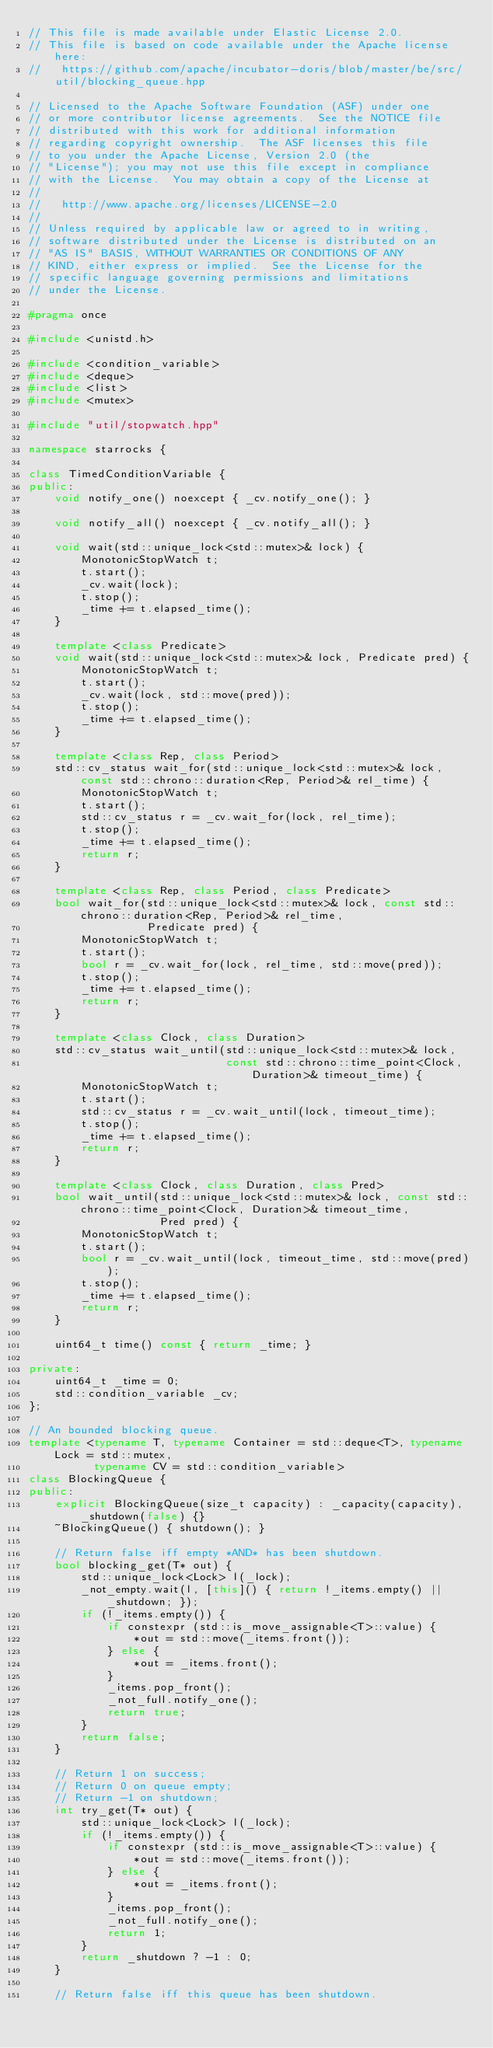Convert code to text. <code><loc_0><loc_0><loc_500><loc_500><_C++_>// This file is made available under Elastic License 2.0.
// This file is based on code available under the Apache license here:
//   https://github.com/apache/incubator-doris/blob/master/be/src/util/blocking_queue.hpp

// Licensed to the Apache Software Foundation (ASF) under one
// or more contributor license agreements.  See the NOTICE file
// distributed with this work for additional information
// regarding copyright ownership.  The ASF licenses this file
// to you under the Apache License, Version 2.0 (the
// "License"); you may not use this file except in compliance
// with the License.  You may obtain a copy of the License at
//
//   http://www.apache.org/licenses/LICENSE-2.0
//
// Unless required by applicable law or agreed to in writing,
// software distributed under the License is distributed on an
// "AS IS" BASIS, WITHOUT WARRANTIES OR CONDITIONS OF ANY
// KIND, either express or implied.  See the License for the
// specific language governing permissions and limitations
// under the License.

#pragma once

#include <unistd.h>

#include <condition_variable>
#include <deque>
#include <list>
#include <mutex>

#include "util/stopwatch.hpp"

namespace starrocks {

class TimedConditionVariable {
public:
    void notify_one() noexcept { _cv.notify_one(); }

    void notify_all() noexcept { _cv.notify_all(); }

    void wait(std::unique_lock<std::mutex>& lock) {
        MonotonicStopWatch t;
        t.start();
        _cv.wait(lock);
        t.stop();
        _time += t.elapsed_time();
    }

    template <class Predicate>
    void wait(std::unique_lock<std::mutex>& lock, Predicate pred) {
        MonotonicStopWatch t;
        t.start();
        _cv.wait(lock, std::move(pred));
        t.stop();
        _time += t.elapsed_time();
    }

    template <class Rep, class Period>
    std::cv_status wait_for(std::unique_lock<std::mutex>& lock, const std::chrono::duration<Rep, Period>& rel_time) {
        MonotonicStopWatch t;
        t.start();
        std::cv_status r = _cv.wait_for(lock, rel_time);
        t.stop();
        _time += t.elapsed_time();
        return r;
    }

    template <class Rep, class Period, class Predicate>
    bool wait_for(std::unique_lock<std::mutex>& lock, const std::chrono::duration<Rep, Period>& rel_time,
                  Predicate pred) {
        MonotonicStopWatch t;
        t.start();
        bool r = _cv.wait_for(lock, rel_time, std::move(pred));
        t.stop();
        _time += t.elapsed_time();
        return r;
    }

    template <class Clock, class Duration>
    std::cv_status wait_until(std::unique_lock<std::mutex>& lock,
                              const std::chrono::time_point<Clock, Duration>& timeout_time) {
        MonotonicStopWatch t;
        t.start();
        std::cv_status r = _cv.wait_until(lock, timeout_time);
        t.stop();
        _time += t.elapsed_time();
        return r;
    }

    template <class Clock, class Duration, class Pred>
    bool wait_until(std::unique_lock<std::mutex>& lock, const std::chrono::time_point<Clock, Duration>& timeout_time,
                    Pred pred) {
        MonotonicStopWatch t;
        t.start();
        bool r = _cv.wait_until(lock, timeout_time, std::move(pred));
        t.stop();
        _time += t.elapsed_time();
        return r;
    }

    uint64_t time() const { return _time; }

private:
    uint64_t _time = 0;
    std::condition_variable _cv;
};

// An bounded blocking queue.
template <typename T, typename Container = std::deque<T>, typename Lock = std::mutex,
          typename CV = std::condition_variable>
class BlockingQueue {
public:
    explicit BlockingQueue(size_t capacity) : _capacity(capacity), _shutdown(false) {}
    ~BlockingQueue() { shutdown(); }

    // Return false iff empty *AND* has been shutdown.
    bool blocking_get(T* out) {
        std::unique_lock<Lock> l(_lock);
        _not_empty.wait(l, [this]() { return !_items.empty() || _shutdown; });
        if (!_items.empty()) {
            if constexpr (std::is_move_assignable<T>::value) {
                *out = std::move(_items.front());
            } else {
                *out = _items.front();
            }
            _items.pop_front();
            _not_full.notify_one();
            return true;
        }
        return false;
    }

    // Return 1 on success;
    // Return 0 on queue empty;
    // Return -1 on shutdown;
    int try_get(T* out) {
        std::unique_lock<Lock> l(_lock);
        if (!_items.empty()) {
            if constexpr (std::is_move_assignable<T>::value) {
                *out = std::move(_items.front());
            } else {
                *out = _items.front();
            }
            _items.pop_front();
            _not_full.notify_one();
            return 1;
        }
        return _shutdown ? -1 : 0;
    }

    // Return false iff this queue has been shutdown.</code> 